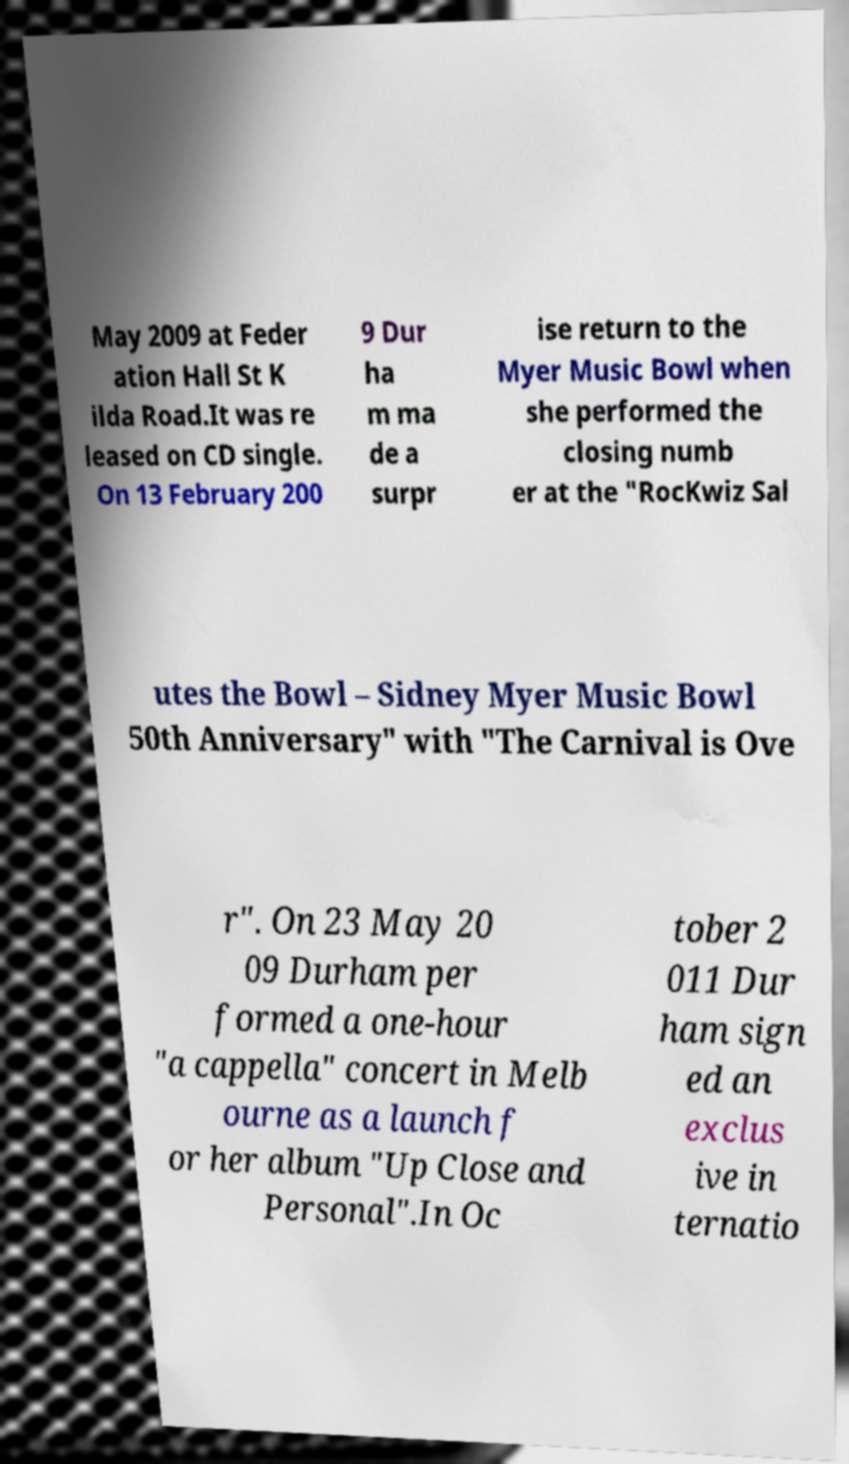What messages or text are displayed in this image? I need them in a readable, typed format. May 2009 at Feder ation Hall St K ilda Road.It was re leased on CD single. On 13 February 200 9 Dur ha m ma de a surpr ise return to the Myer Music Bowl when she performed the closing numb er at the "RocKwiz Sal utes the Bowl – Sidney Myer Music Bowl 50th Anniversary" with "The Carnival is Ove r". On 23 May 20 09 Durham per formed a one-hour "a cappella" concert in Melb ourne as a launch f or her album "Up Close and Personal".In Oc tober 2 011 Dur ham sign ed an exclus ive in ternatio 